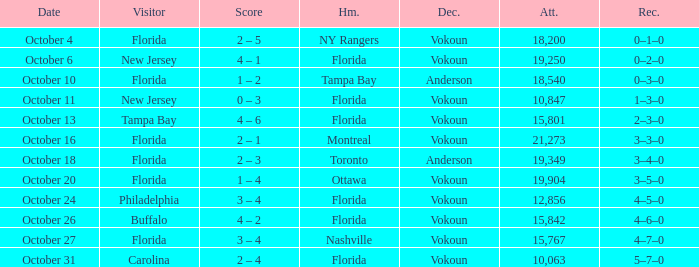What was the score on October 13? 4 – 6. 